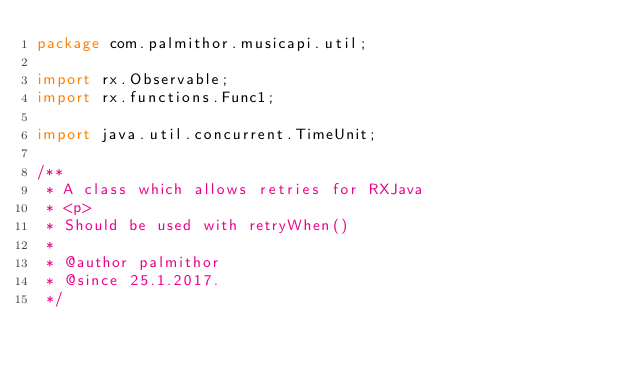Convert code to text. <code><loc_0><loc_0><loc_500><loc_500><_Java_>package com.palmithor.musicapi.util;

import rx.Observable;
import rx.functions.Func1;

import java.util.concurrent.TimeUnit;

/**
 * A class which allows retries for RXJava
 * <p>
 * Should be used with retryWhen()
 *
 * @author palmithor
 * @since 25.1.2017.
 */</code> 